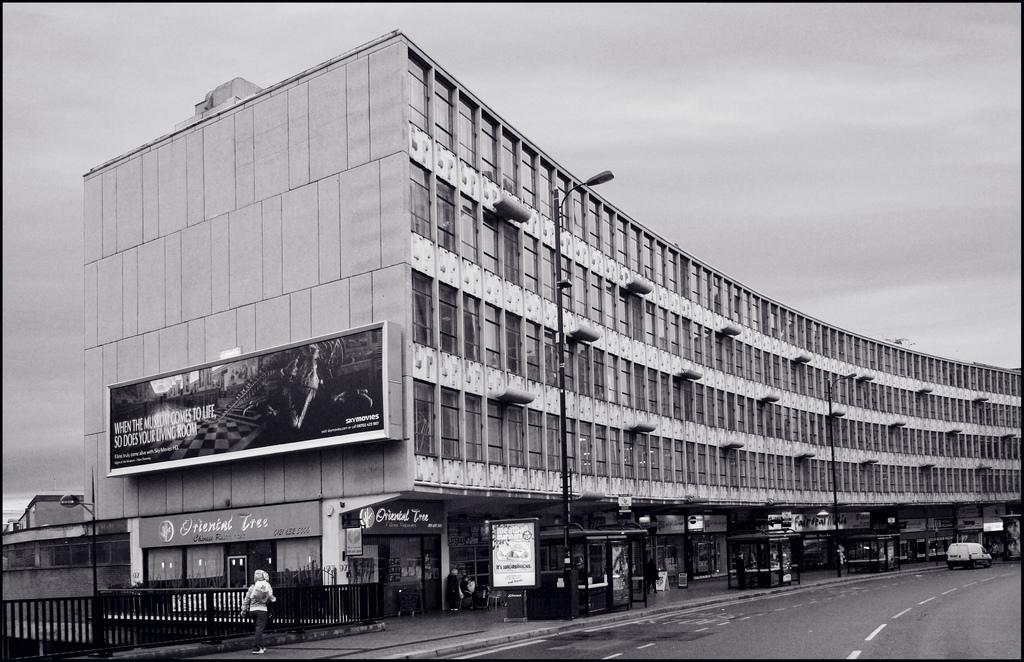Can you describe this image briefly? This is a black and white image. In this image, I can see a building. In the bottom right-hand corner there is a vehicle on the road. Beside the road there are few light poles. In the bottom left-hand corner there is a person walking on the footpath and also there is a railing. At the top of the image, I can see the sky. 